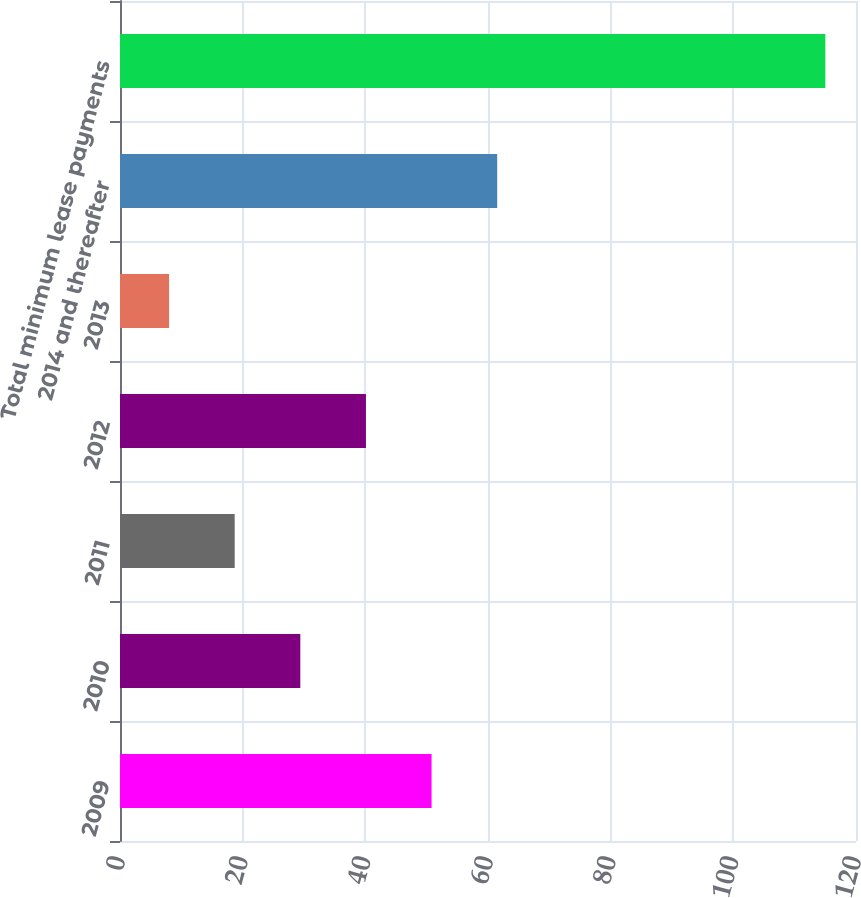Convert chart to OTSL. <chart><loc_0><loc_0><loc_500><loc_500><bar_chart><fcel>2009<fcel>2010<fcel>2011<fcel>2012<fcel>2013<fcel>2014 and thereafter<fcel>Total minimum lease payments<nl><fcel>50.8<fcel>29.4<fcel>18.7<fcel>40.1<fcel>8<fcel>61.5<fcel>115<nl></chart> 